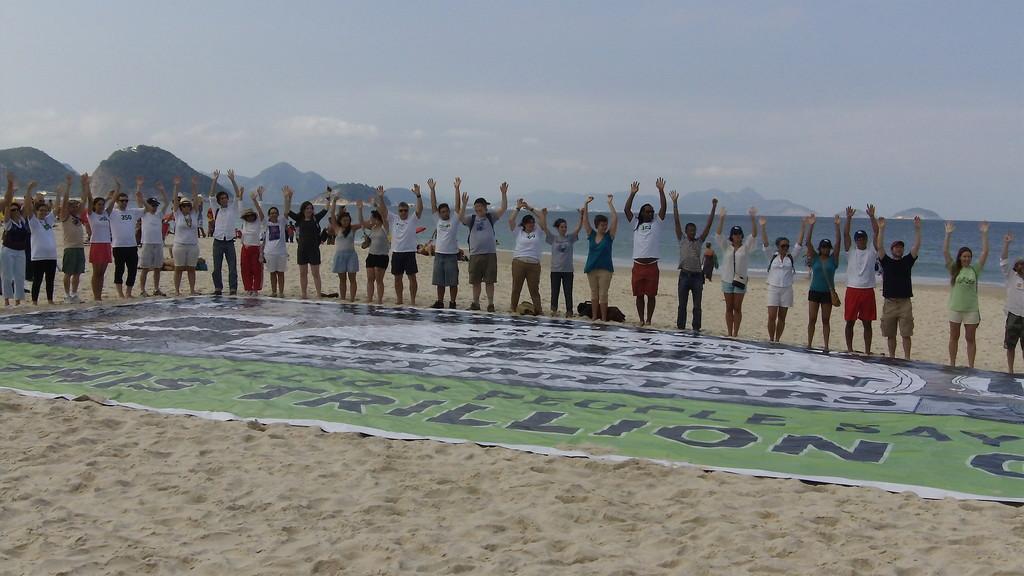Can you describe this image briefly? In the foreground of this picture, there are persons standing on the sand and raising their hands up in front of them there is a big banner. In the background, there are mountains, sky and the water. 